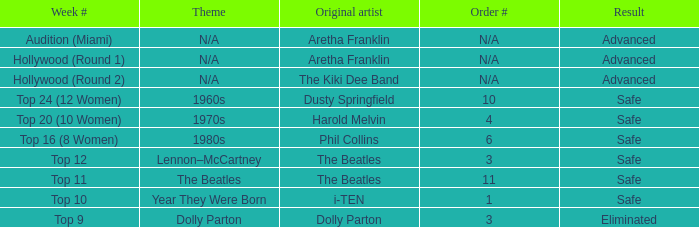What is the first artist who has a sequence number of 11? The Beatles. 